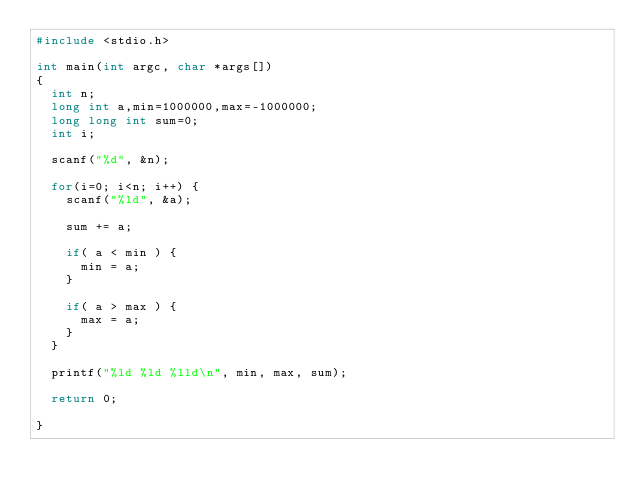<code> <loc_0><loc_0><loc_500><loc_500><_C_>#include <stdio.h>

int main(int argc, char *args[])
{
	int n;
	long int a,min=1000000,max=-1000000;
	long long int sum=0;
	int i;

	scanf("%d", &n);

	for(i=0; i<n; i++) {
		scanf("%ld", &a);

		sum += a;

		if( a < min ) {
			min = a;
		}

		if( a > max ) {
			max = a;
		}
	}

	printf("%ld %ld %lld\n", min, max, sum);

	return 0;

}</code> 